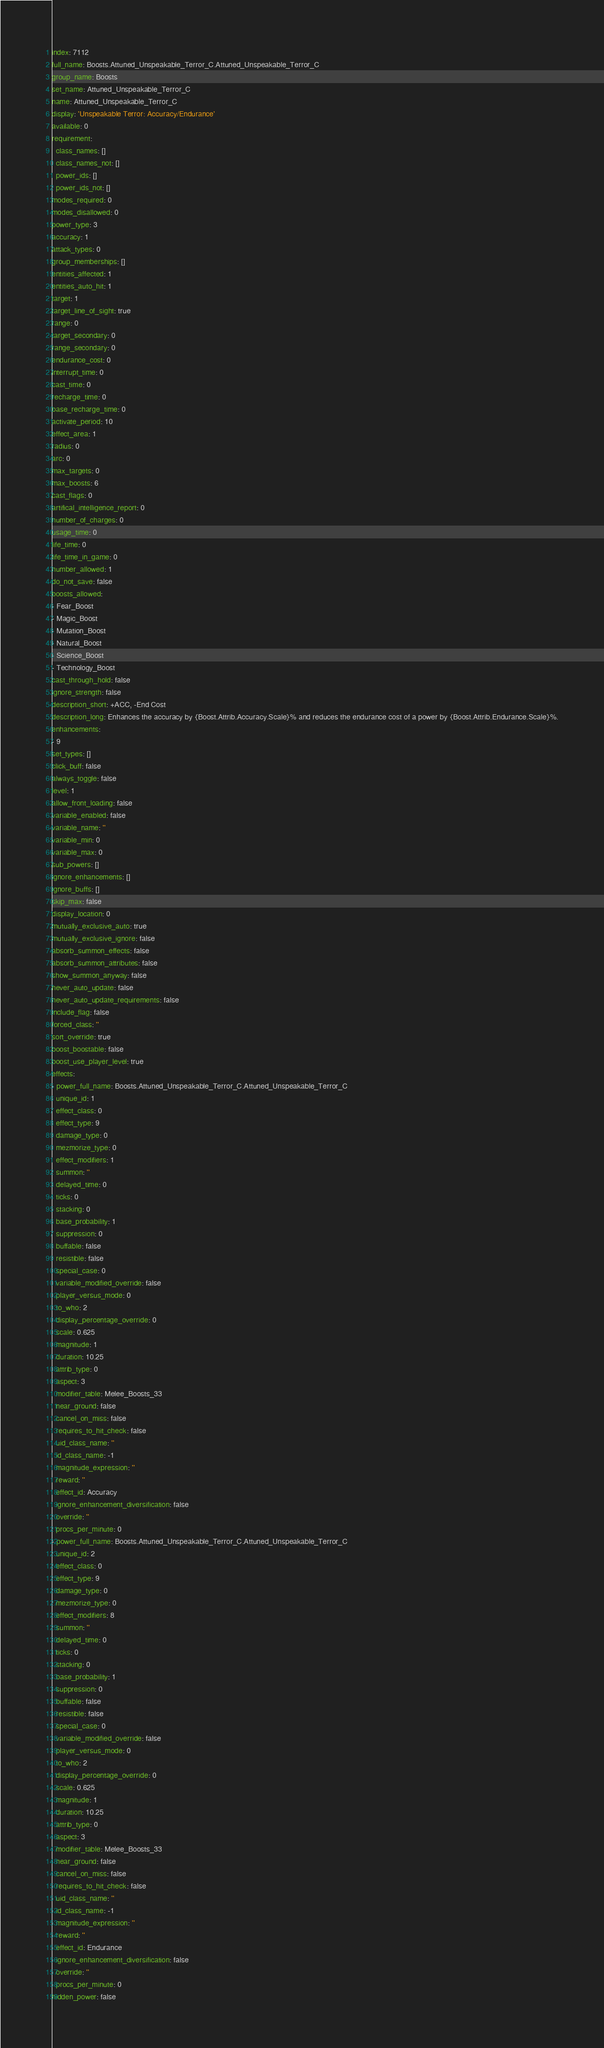Convert code to text. <code><loc_0><loc_0><loc_500><loc_500><_YAML_>index: 7112
full_name: Boosts.Attuned_Unspeakable_Terror_C.Attuned_Unspeakable_Terror_C
group_name: Boosts
set_name: Attuned_Unspeakable_Terror_C
name: Attuned_Unspeakable_Terror_C
display: 'Unspeakable Terror: Accuracy/Endurance'
available: 0
requirement:
  class_names: []
  class_names_not: []
  power_ids: []
  power_ids_not: []
modes_required: 0
modes_disallowed: 0
power_type: 3
accuracy: 1
attack_types: 0
group_memberships: []
entities_affected: 1
entities_auto_hit: 1
target: 1
target_line_of_sight: true
range: 0
target_secondary: 0
range_secondary: 0
endurance_cost: 0
interrupt_time: 0
cast_time: 0
recharge_time: 0
base_recharge_time: 0
activate_period: 10
effect_area: 1
radius: 0
arc: 0
max_targets: 0
max_boosts: 6
cast_flags: 0
artifical_intelligence_report: 0
number_of_charges: 0
usage_time: 0
life_time: 0
life_time_in_game: 0
number_allowed: 1
do_not_save: false
boosts_allowed:
- Fear_Boost
- Magic_Boost
- Mutation_Boost
- Natural_Boost
- Science_Boost
- Technology_Boost
cast_through_hold: false
ignore_strength: false
description_short: +ACC, -End Cost
description_long: Enhances the accuracy by {Boost.Attrib.Accuracy.Scale}% and reduces the endurance cost of a power by {Boost.Attrib.Endurance.Scale}%.
enhancements:
- 9
set_types: []
click_buff: false
always_toggle: false
level: 1
allow_front_loading: false
variable_enabled: false
variable_name: ''
variable_min: 0
variable_max: 0
sub_powers: []
ignore_enhancements: []
ignore_buffs: []
skip_max: false
display_location: 0
mutually_exclusive_auto: true
mutually_exclusive_ignore: false
absorb_summon_effects: false
absorb_summon_attributes: false
show_summon_anyway: false
never_auto_update: false
never_auto_update_requirements: false
include_flag: false
forced_class: ''
sort_override: true
boost_boostable: false
boost_use_player_level: true
effects:
- power_full_name: Boosts.Attuned_Unspeakable_Terror_C.Attuned_Unspeakable_Terror_C
  unique_id: 1
  effect_class: 0
  effect_type: 9
  damage_type: 0
  mezmorize_type: 0
  effect_modifiers: 1
  summon: ''
  delayed_time: 0
  ticks: 0
  stacking: 0
  base_probability: 1
  suppression: 0
  buffable: false
  resistible: false
  special_case: 0
  variable_modified_override: false
  player_versus_mode: 0
  to_who: 2
  display_percentage_override: 0
  scale: 0.625
  magnitude: 1
  duration: 10.25
  attrib_type: 0
  aspect: 3
  modifier_table: Melee_Boosts_33
  near_ground: false
  cancel_on_miss: false
  requires_to_hit_check: false
  uid_class_name: ''
  id_class_name: -1
  magnitude_expression: ''
  reward: ''
  effect_id: Accuracy
  ignore_enhancement_diversification: false
  override: ''
  procs_per_minute: 0
- power_full_name: Boosts.Attuned_Unspeakable_Terror_C.Attuned_Unspeakable_Terror_C
  unique_id: 2
  effect_class: 0
  effect_type: 9
  damage_type: 0
  mezmorize_type: 0
  effect_modifiers: 8
  summon: ''
  delayed_time: 0
  ticks: 0
  stacking: 0
  base_probability: 1
  suppression: 0
  buffable: false
  resistible: false
  special_case: 0
  variable_modified_override: false
  player_versus_mode: 0
  to_who: 2
  display_percentage_override: 0
  scale: 0.625
  magnitude: 1
  duration: 10.25
  attrib_type: 0
  aspect: 3
  modifier_table: Melee_Boosts_33
  near_ground: false
  cancel_on_miss: false
  requires_to_hit_check: false
  uid_class_name: ''
  id_class_name: -1
  magnitude_expression: ''
  reward: ''
  effect_id: Endurance
  ignore_enhancement_diversification: false
  override: ''
  procs_per_minute: 0
hidden_power: false
</code> 